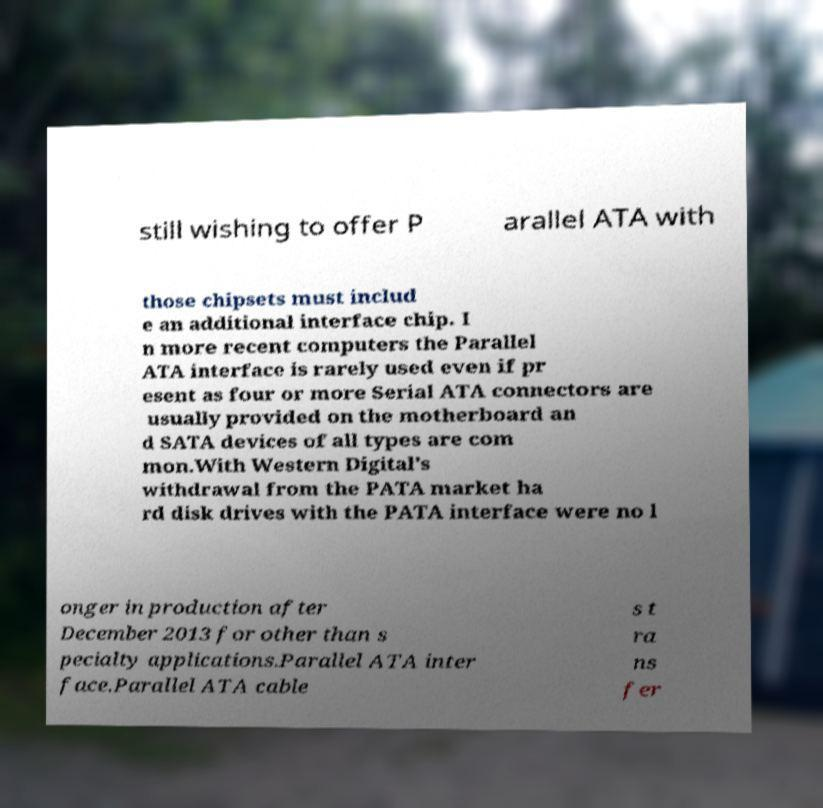Can you accurately transcribe the text from the provided image for me? still wishing to offer P arallel ATA with those chipsets must includ e an additional interface chip. I n more recent computers the Parallel ATA interface is rarely used even if pr esent as four or more Serial ATA connectors are usually provided on the motherboard an d SATA devices of all types are com mon.With Western Digital's withdrawal from the PATA market ha rd disk drives with the PATA interface were no l onger in production after December 2013 for other than s pecialty applications.Parallel ATA inter face.Parallel ATA cable s t ra ns fer 